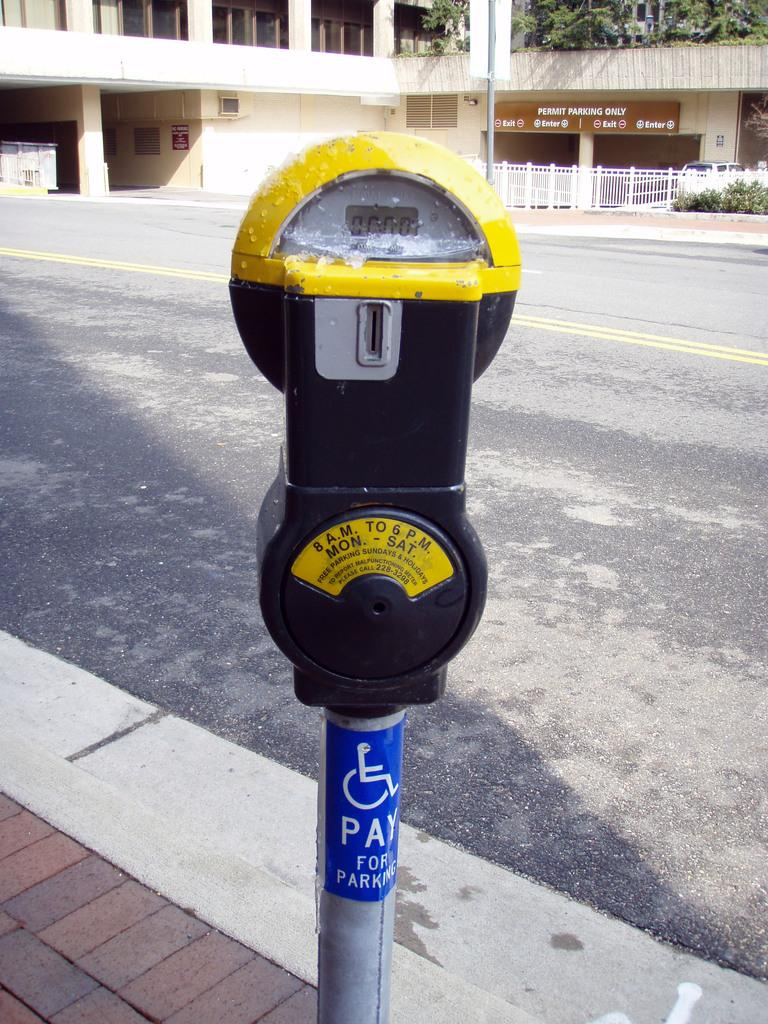<image>
Describe the image concisely. A parking meter with a blue sticker with a wheel chair that says pay for parking. 